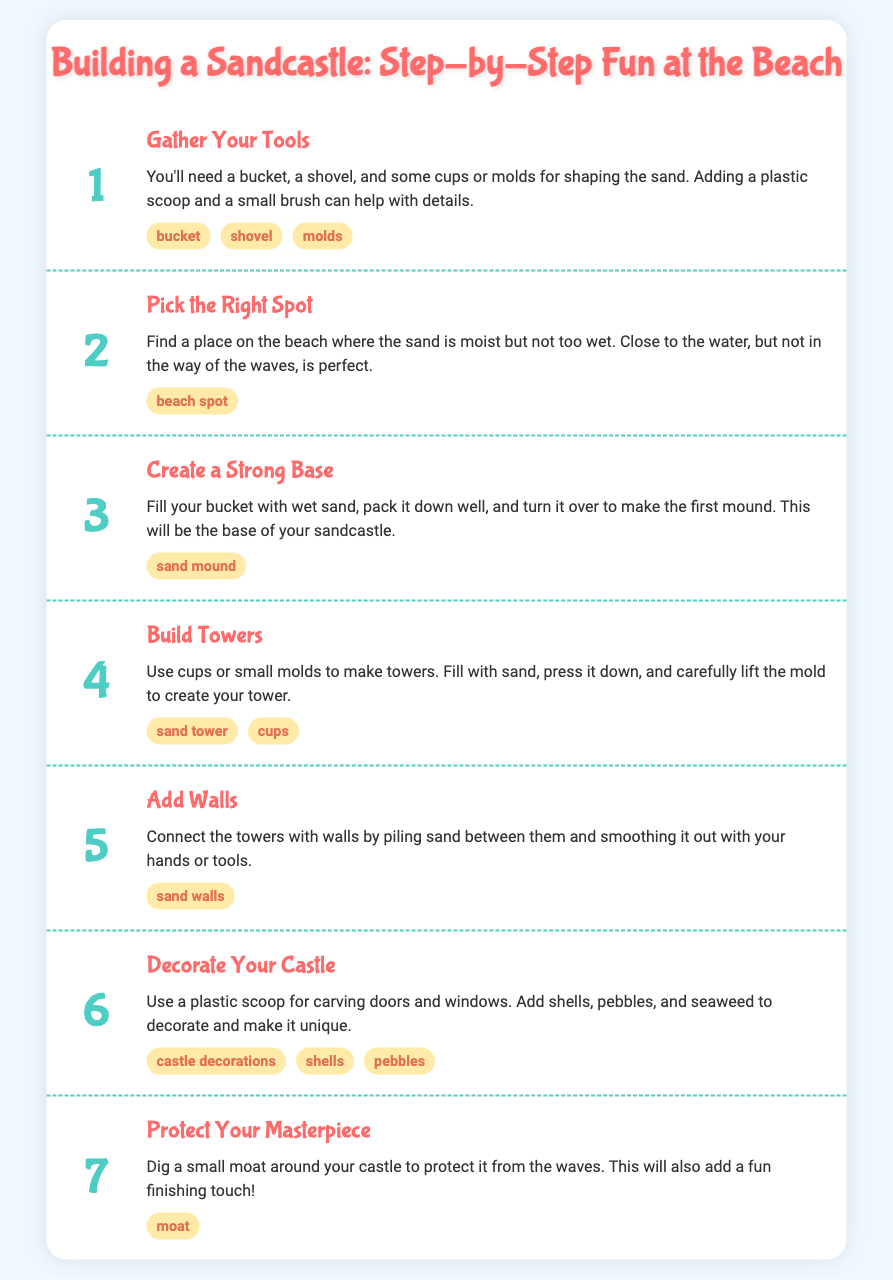What is the first step in building a sandcastle? The first step in the process is to gather the necessary tools for building a sandcastle.
Answer: Gather Your Tools What do you need to make towers? To make towers, you need cups or small molds to fill with sand and shape.
Answer: cups or small molds How many total steps are in the process? The document outlines a total of seven distinct steps involved in building a sandcastle.
Answer: 7 What should you create as the base of the sandcastle? The base of the sandcastle should be a mound created by packing wet sand into a bucket.
Answer: sand mound What is used to decorate the sandcastle? Shells, pebbles, and seaweed can be used as decorations to enhance the appearance of your sandcastle.
Answer: shells, pebbles, seaweed Where should you build your sandcastle? It is best to build your sandcastle in a spot that is moist but not too wet, close to the water but not where waves come in.
Answer: beach spot What is a fun finishing touch to the castle? Digging a small moat around the castle adds a fun finishing touch and helps protect it from waves.
Answer: moat What tool aids in carving doors and windows? A plastic scoop is the tool that helps carve doors and windows in the sandcastle.
Answer: plastic scoop 